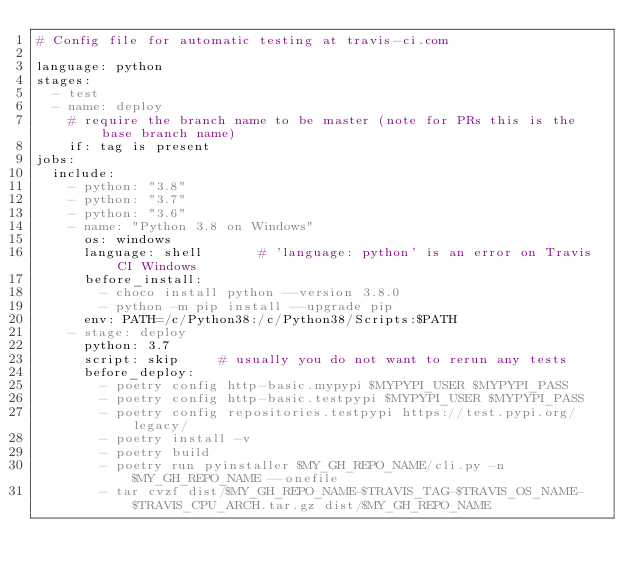Convert code to text. <code><loc_0><loc_0><loc_500><loc_500><_YAML_># Config file for automatic testing at travis-ci.com

language: python
stages:
  - test
  - name: deploy
    # require the branch name to be master (note for PRs this is the base branch name)
    if: tag is present
jobs:
  include:
    - python: "3.8"
    - python: "3.7"
    - python: "3.6"
    - name: "Python 3.8 on Windows"
      os: windows
      language: shell       # 'language: python' is an error on Travis CI Windows
      before_install:
        - choco install python --version 3.8.0
        - python -m pip install --upgrade pip
      env: PATH=/c/Python38:/c/Python38/Scripts:$PATH
    - stage: deploy
      python: 3.7
      script: skip     # usually you do not want to rerun any tests
      before_deploy:
        - poetry config http-basic.mypypi $MYPYPI_USER $MYPYPI_PASS
        - poetry config http-basic.testpypi $MYPYPI_USER $MYPYPI_PASS
        - poetry config repositories.testpypi https://test.pypi.org/legacy/
        - poetry install -v
        - poetry build
        - poetry run pyinstaller $MY_GH_REPO_NAME/cli.py -n $MY_GH_REPO_NAME --onefile
        - tar cvzf dist/$MY_GH_REPO_NAME-$TRAVIS_TAG-$TRAVIS_OS_NAME-$TRAVIS_CPU_ARCH.tar.gz dist/$MY_GH_REPO_NAME</code> 